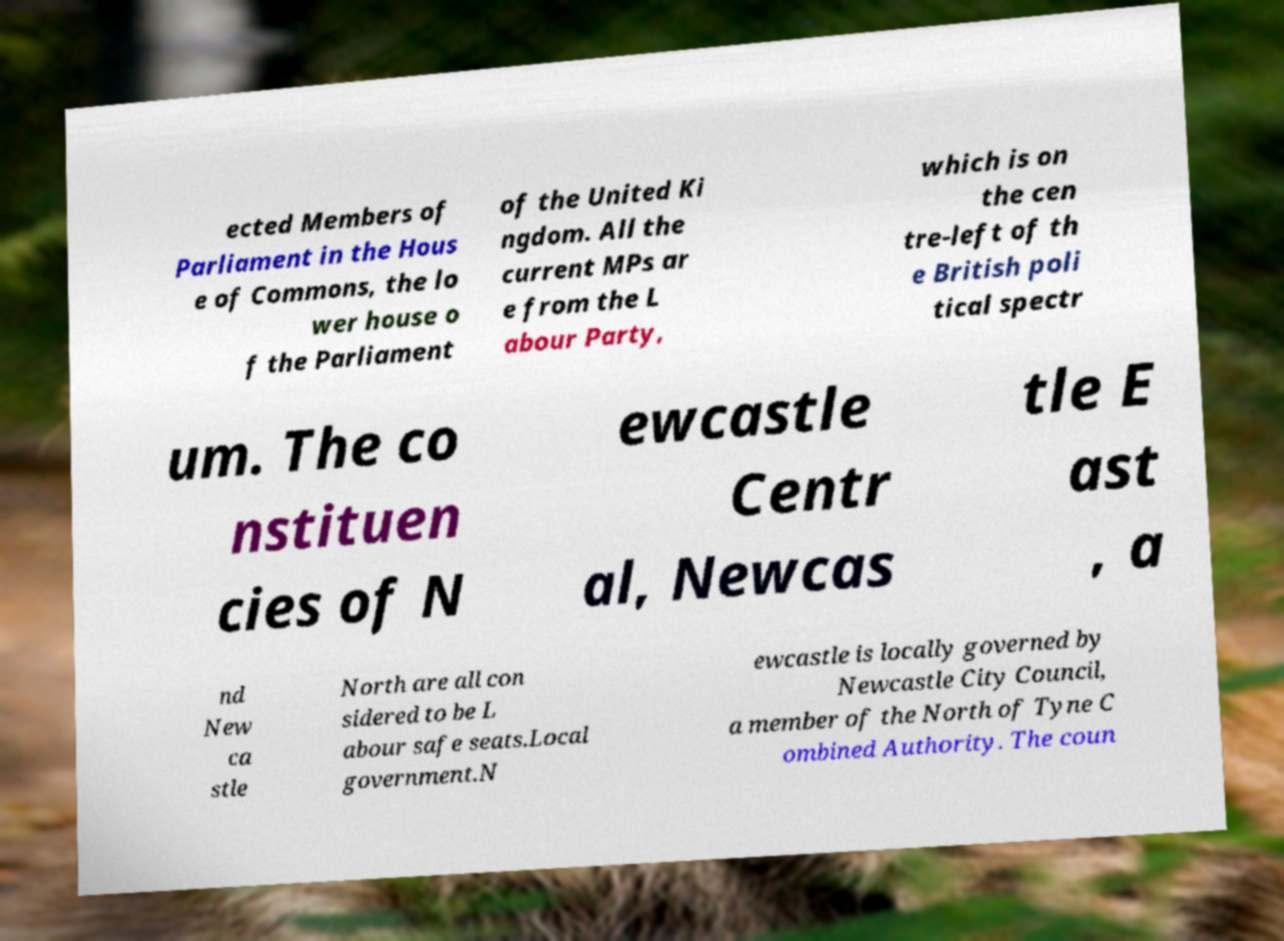For documentation purposes, I need the text within this image transcribed. Could you provide that? ected Members of Parliament in the Hous e of Commons, the lo wer house o f the Parliament of the United Ki ngdom. All the current MPs ar e from the L abour Party, which is on the cen tre-left of th e British poli tical spectr um. The co nstituen cies of N ewcastle Centr al, Newcas tle E ast , a nd New ca stle North are all con sidered to be L abour safe seats.Local government.N ewcastle is locally governed by Newcastle City Council, a member of the North of Tyne C ombined Authority. The coun 